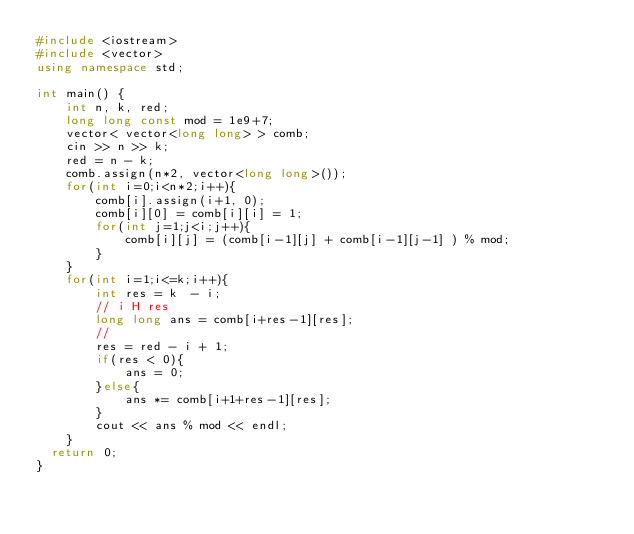Convert code to text. <code><loc_0><loc_0><loc_500><loc_500><_C++_>#include <iostream>
#include <vector>
using namespace std;

int main() {
    int n, k, red;
    long long const mod = 1e9+7;
    vector< vector<long long> > comb;
    cin >> n >> k;
    red = n - k;
    comb.assign(n*2, vector<long long>());
    for(int i=0;i<n*2;i++){
        comb[i].assign(i+1, 0);
        comb[i][0] = comb[i][i] = 1;
        for(int j=1;j<i;j++){
            comb[i][j] = (comb[i-1][j] + comb[i-1][j-1] ) % mod;
        }
    }
    for(int i=1;i<=k;i++){
        int res = k  - i;
        // i H res
        long long ans = comb[i+res-1][res];
        //
        res = red - i + 1;
        if(res < 0){
            ans = 0;
        }else{
            ans *= comb[i+1+res-1][res];
        }
        cout << ans % mod << endl;
    }
	return 0;
}
</code> 